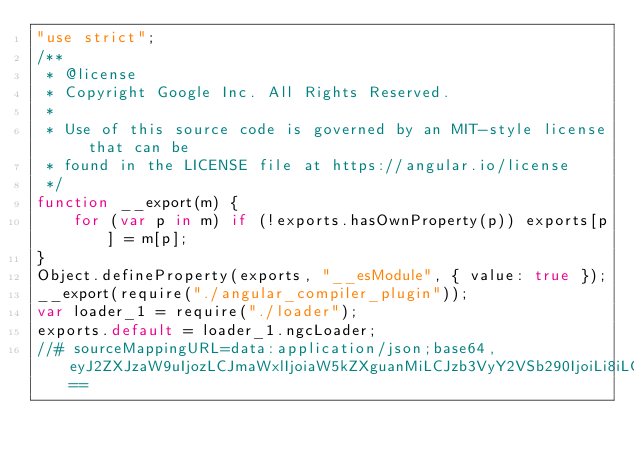Convert code to text. <code><loc_0><loc_0><loc_500><loc_500><_JavaScript_>"use strict";
/**
 * @license
 * Copyright Google Inc. All Rights Reserved.
 *
 * Use of this source code is governed by an MIT-style license that can be
 * found in the LICENSE file at https://angular.io/license
 */
function __export(m) {
    for (var p in m) if (!exports.hasOwnProperty(p)) exports[p] = m[p];
}
Object.defineProperty(exports, "__esModule", { value: true });
__export(require("./angular_compiler_plugin"));
var loader_1 = require("./loader");
exports.default = loader_1.ngcLoader;
//# sourceMappingURL=data:application/json;base64,eyJ2ZXJzaW9uIjozLCJmaWxlIjoiaW5kZXguanMiLCJzb3VyY2VSb290IjoiLi8iLCJzb3VyY2VzIjpbInBhY2thZ2VzL25ndG9vbHMvd2VicGFjay9zcmMvaW5kZXgudHMiXSwibmFtZXMiOltdLCJtYXBwaW5ncyI6IjtBQUFBOzs7Ozs7R0FNRzs7Ozs7QUFFSCwrQ0FBMEM7QUFDMUMsbUNBQWdEO0FBQXZDLDJCQUFBLFNBQVMsQ0FBVyIsInNvdXJjZXNDb250ZW50IjpbIi8qKlxuICogQGxpY2Vuc2VcbiAqIENvcHlyaWdodCBHb29nbGUgSW5jLiBBbGwgUmlnaHRzIFJlc2VydmVkLlxuICpcbiAqIFVzZSBvZiB0aGlzIHNvdXJjZSBjb2RlIGlzIGdvdmVybmVkIGJ5IGFuIE1JVC1zdHlsZSBsaWNlbnNlIHRoYXQgY2FuIGJlXG4gKiBmb3VuZCBpbiB0aGUgTElDRU5TRSBmaWxlIGF0IGh0dHBzOi8vYW5ndWxhci5pby9saWNlbnNlXG4gKi9cblxuZXhwb3J0ICogZnJvbSAnLi9hbmd1bGFyX2NvbXBpbGVyX3BsdWdpbic7XG5leHBvcnQgeyBuZ2NMb2FkZXIgYXMgZGVmYXVsdCB9IGZyb20gJy4vbG9hZGVyJztcbiJdfQ==</code> 